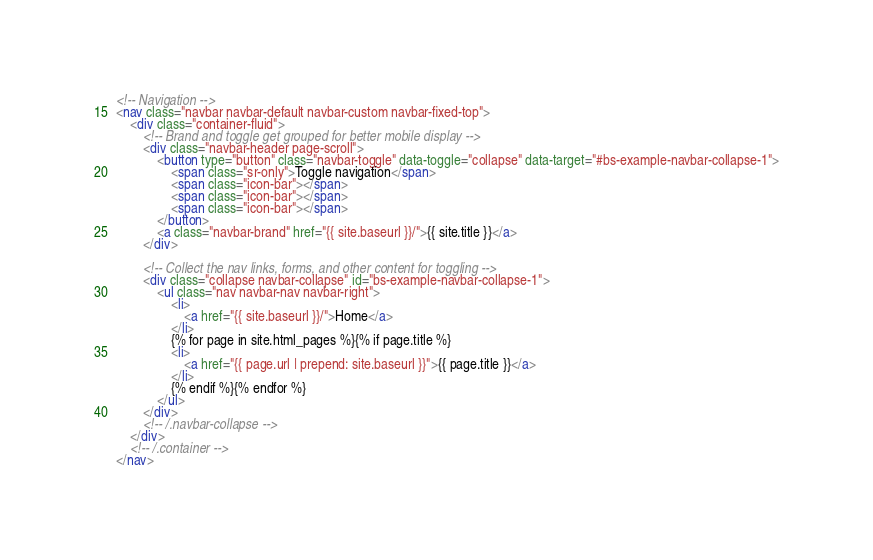<code> <loc_0><loc_0><loc_500><loc_500><_HTML_><!-- Navigation -->
<nav class="navbar navbar-default navbar-custom navbar-fixed-top">
    <div class="container-fluid">
        <!-- Brand and toggle get grouped for better mobile display -->
        <div class="navbar-header page-scroll">
            <button type="button" class="navbar-toggle" data-toggle="collapse" data-target="#bs-example-navbar-collapse-1">
                <span class="sr-only">Toggle navigation</span>
                <span class="icon-bar"></span>
                <span class="icon-bar"></span>
                <span class="icon-bar"></span>
            </button>
            <a class="navbar-brand" href="{{ site.baseurl }}/">{{ site.title }}</a>
        </div>

        <!-- Collect the nav links, forms, and other content for toggling -->
        <div class="collapse navbar-collapse" id="bs-example-navbar-collapse-1">
            <ul class="nav navbar-nav navbar-right">
                <li>
                    <a href="{{ site.baseurl }}/">Home</a>
                </li>
                {% for page in site.html_pages %}{% if page.title %}
                <li>
                    <a href="{{ page.url | prepend: site.baseurl }}">{{ page.title }}</a>
                </li>
                {% endif %}{% endfor %}
            </ul>
        </div>
        <!-- /.navbar-collapse -->
    </div>
    <!-- /.container -->
</nav>
</code> 